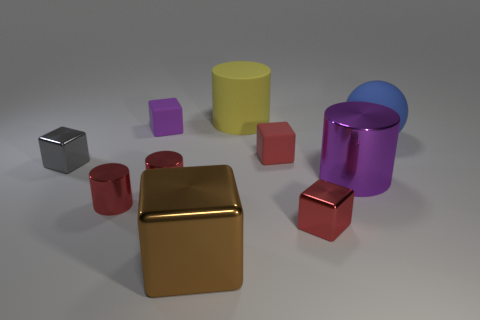Subtract all tiny purple cubes. How many cubes are left? 4 Subtract 1 cubes. How many cubes are left? 4 Subtract all brown blocks. How many blocks are left? 4 Subtract all green blocks. Subtract all red cylinders. How many blocks are left? 5 Subtract all cylinders. How many objects are left? 6 Subtract all large yellow objects. Subtract all small gray metal blocks. How many objects are left? 8 Add 8 blue rubber objects. How many blue rubber objects are left? 9 Add 9 small gray rubber blocks. How many small gray rubber blocks exist? 9 Subtract 0 yellow cubes. How many objects are left? 10 